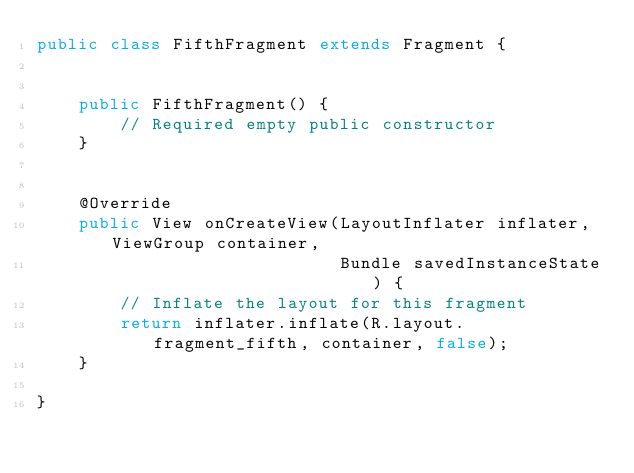<code> <loc_0><loc_0><loc_500><loc_500><_Java_>public class FifthFragment extends Fragment {


    public FifthFragment() {
        // Required empty public constructor
    }


    @Override
    public View onCreateView(LayoutInflater inflater, ViewGroup container,
                             Bundle savedInstanceState) {
        // Inflate the layout for this fragment
        return inflater.inflate(R.layout.fragment_fifth, container, false);
    }

}
</code> 